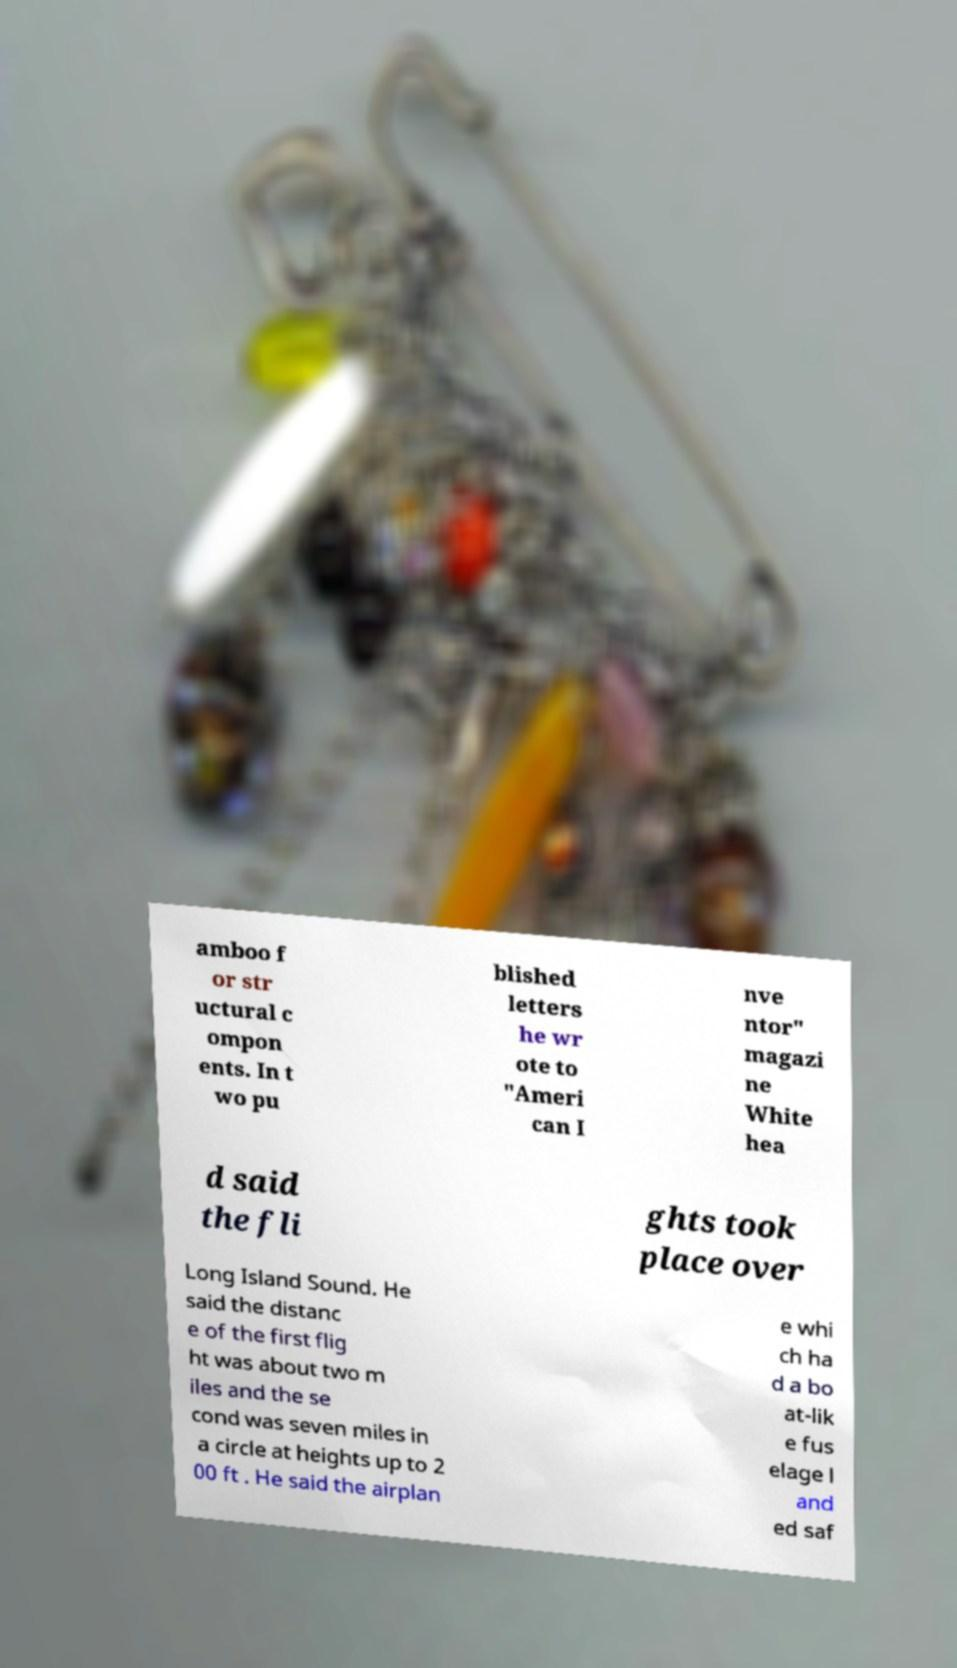Can you accurately transcribe the text from the provided image for me? amboo f or str uctural c ompon ents. In t wo pu blished letters he wr ote to "Ameri can I nve ntor" magazi ne White hea d said the fli ghts took place over Long Island Sound. He said the distanc e of the first flig ht was about two m iles and the se cond was seven miles in a circle at heights up to 2 00 ft . He said the airplan e whi ch ha d a bo at-lik e fus elage l and ed saf 